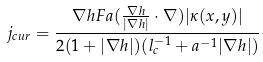Convert formula to latex. <formula><loc_0><loc_0><loc_500><loc_500>j _ { c u r } = \frac { \nabla h F a ( \frac { \nabla h } { | \nabla h | } \cdot \nabla ) | \kappa ( x , y ) | } { 2 ( 1 + | \nabla h | ) ( l _ { c } ^ { - 1 } + a ^ { - 1 } | \nabla h | ) }</formula> 